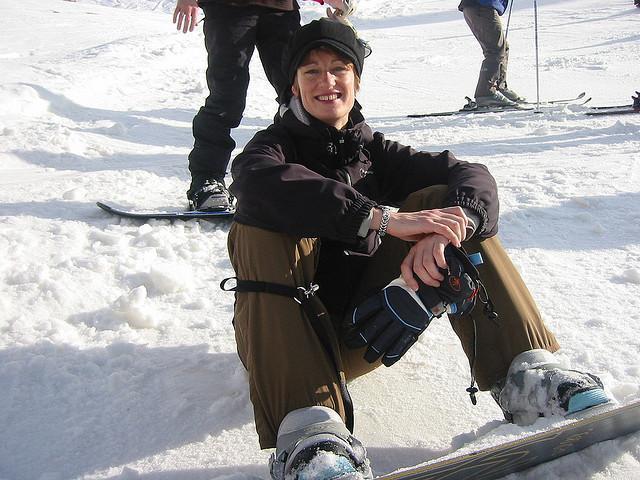How many people are there?
Give a very brief answer. 3. 